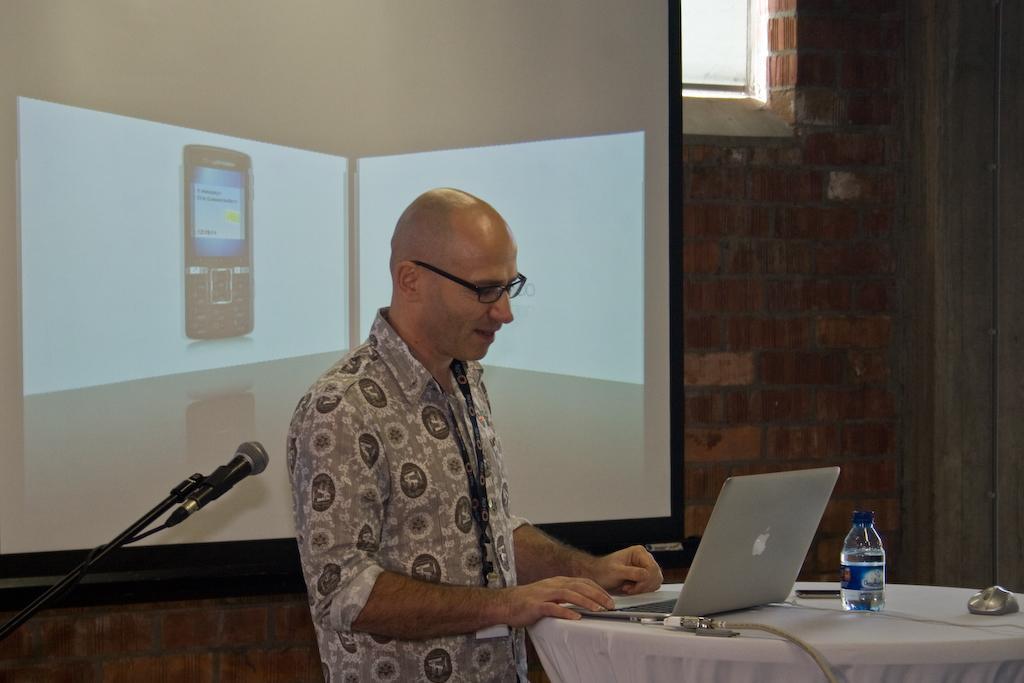Please provide a concise description of this image. In this image there is a man standing facing towards the right side. In front of him there is a table which is covered with a white color cloth. On the table a laptop, bottle and some other objects are placed. The man is looking into the laptop. On the left side there is a mike stand. In the background there is a screen is attached to the wall. On the screen, I can see an image of a mobile 